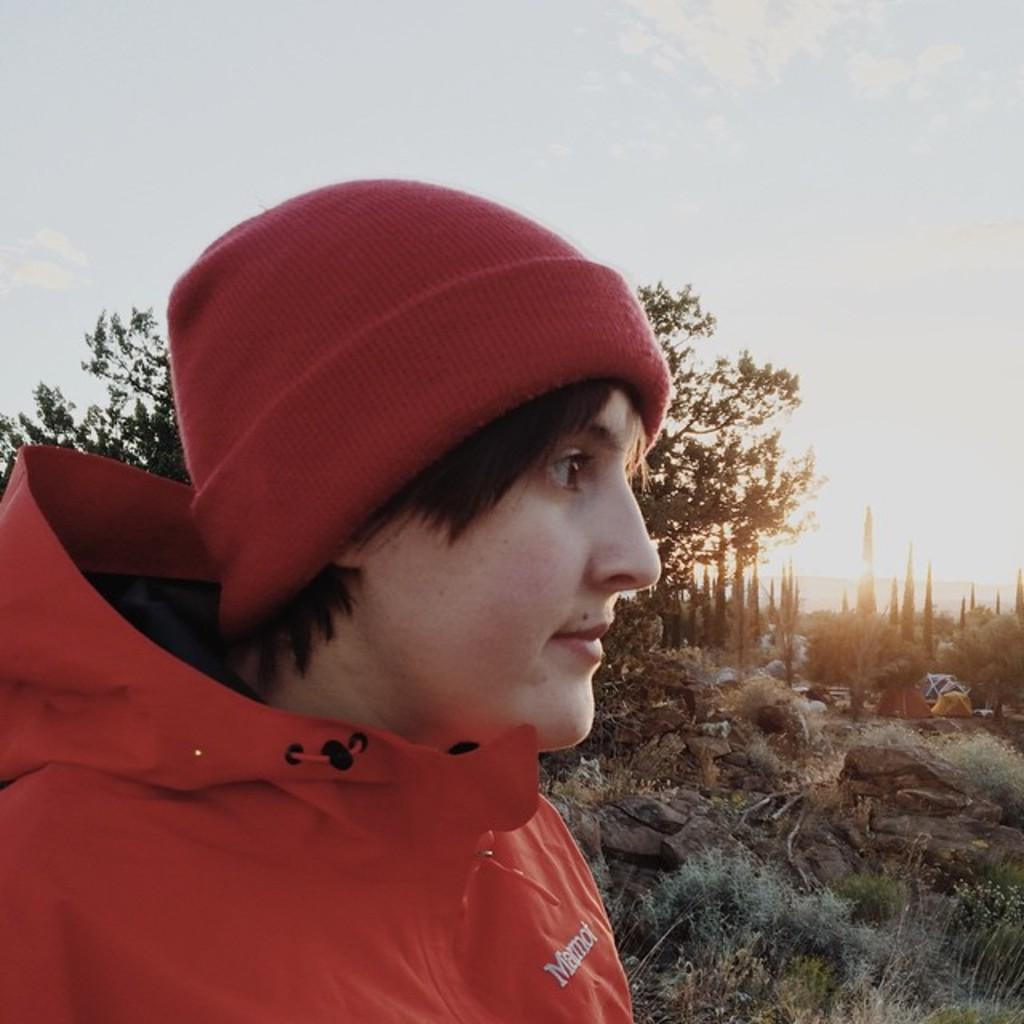What is there is a person in the image, what are they wearing? The person in the image is wearing a dress and cap. What can be seen in the background of the image? There is grass, many trees, and the sky visible in the background of the image. What structures are present to the right of the image? There are tents to the right of the image. What color is the crayon being used by the person in the image? There is no crayon present in the image; the person is wearing a dress and cap. 